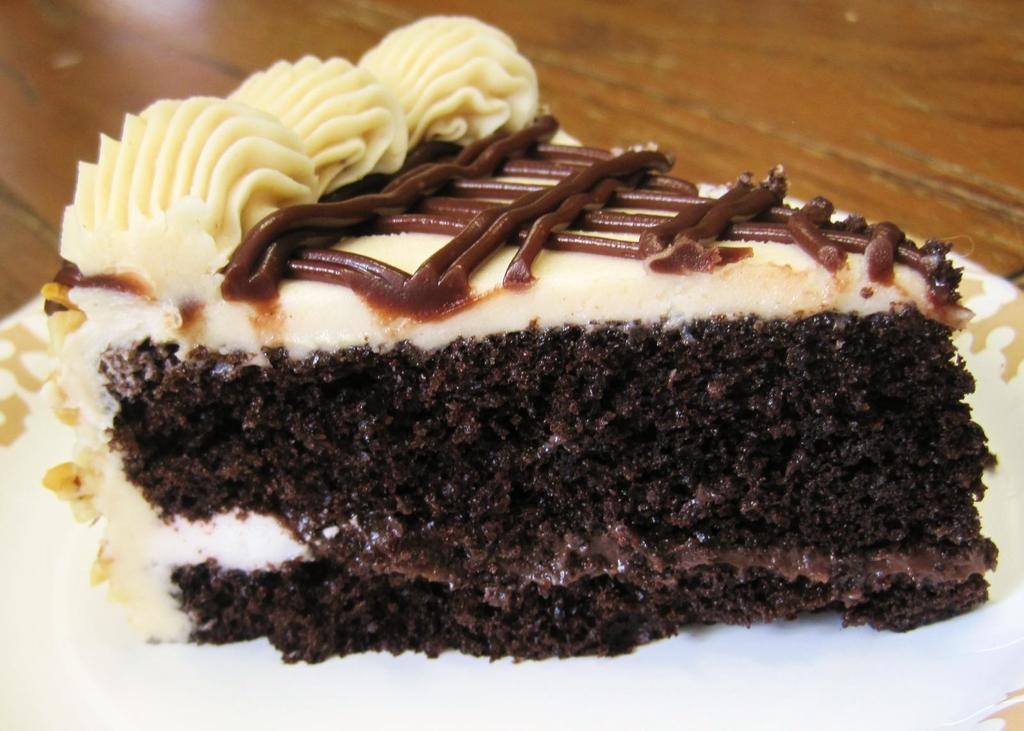What types of items can be seen in the image? There are food items in the image. Where are the food items located? The food items are placed on a surface. What is the size of the beef in the image? There is no beef present in the image, so it is not possible to determine its size. 